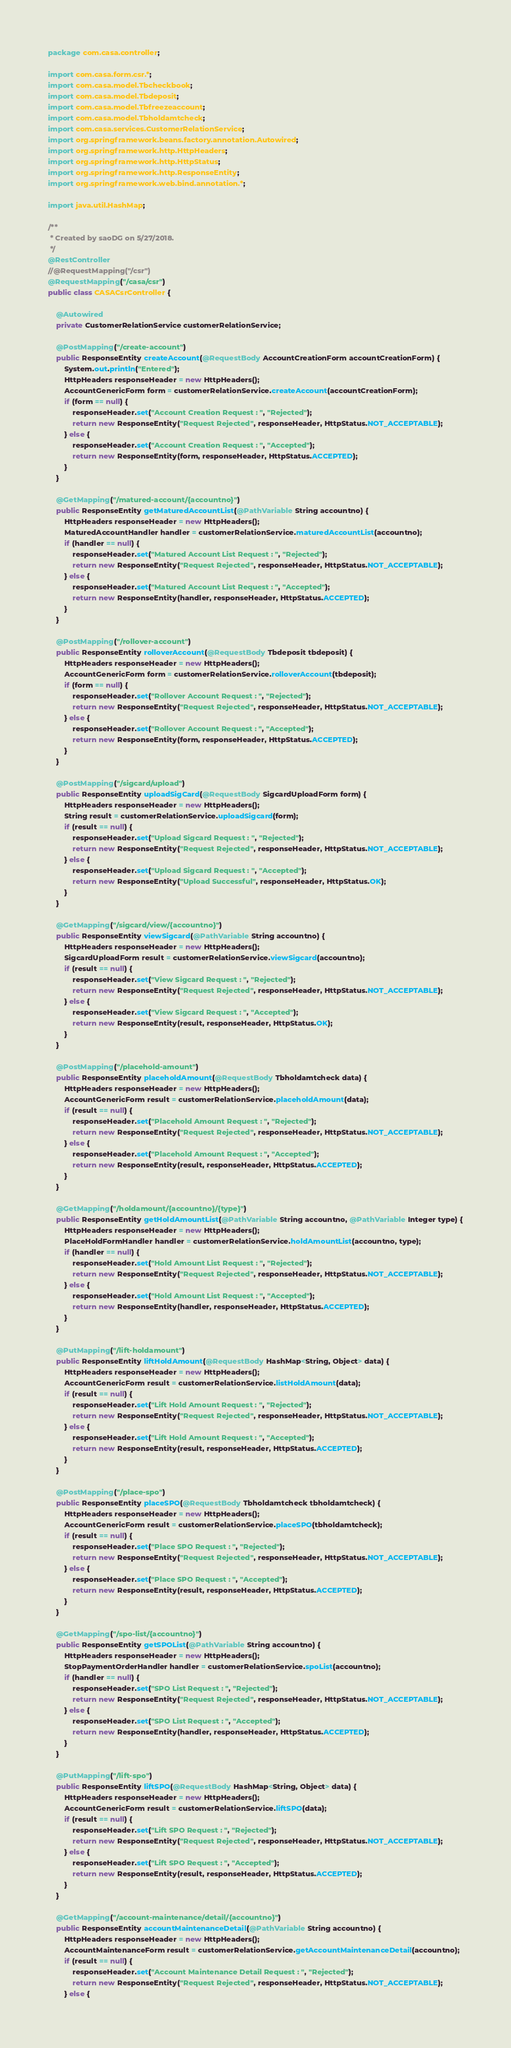Convert code to text. <code><loc_0><loc_0><loc_500><loc_500><_Java_>package com.casa.controller;

import com.casa.form.csr.*;
import com.casa.model.Tbcheckbook;
import com.casa.model.Tbdeposit;
import com.casa.model.Tbfreezeaccount;
import com.casa.model.Tbholdamtcheck;
import com.casa.services.CustomerRelationService;
import org.springframework.beans.factory.annotation.Autowired;
import org.springframework.http.HttpHeaders;
import org.springframework.http.HttpStatus;
import org.springframework.http.ResponseEntity;
import org.springframework.web.bind.annotation.*;

import java.util.HashMap;

/**
 * Created by saoDG on 5/27/2018.
 */
@RestController
//@RequestMapping("/csr")
@RequestMapping("/casa/csr")
public class CASACsrController {

    @Autowired
    private CustomerRelationService customerRelationService;

    @PostMapping("/create-account")
    public ResponseEntity createAccount(@RequestBody AccountCreationForm accountCreationForm) {
        System.out.println("Entered");
        HttpHeaders responseHeader = new HttpHeaders();
        AccountGenericForm form = customerRelationService.createAccount(accountCreationForm);
        if (form == null) {
            responseHeader.set("Account Creation Request : ", "Rejected");
            return new ResponseEntity("Request Rejected", responseHeader, HttpStatus.NOT_ACCEPTABLE);
        } else {
            responseHeader.set("Account Creation Request : ", "Accepted");
            return new ResponseEntity(form, responseHeader, HttpStatus.ACCEPTED);
        }
    }

    @GetMapping("/matured-account/{accountno}")
    public ResponseEntity getMaturedAccountList(@PathVariable String accountno) {
        HttpHeaders responseHeader = new HttpHeaders();
        MaturedAccountHandler handler = customerRelationService.maturedAccountList(accountno);
        if (handler == null) {
            responseHeader.set("Matured Account List Request : ", "Rejected");
            return new ResponseEntity("Request Rejected", responseHeader, HttpStatus.NOT_ACCEPTABLE);
        } else {
            responseHeader.set("Matured Account List Request : ", "Accepted");
            return new ResponseEntity(handler, responseHeader, HttpStatus.ACCEPTED);
        }
    }

    @PostMapping("/rollover-account")
    public ResponseEntity rolloverAccount(@RequestBody Tbdeposit tbdeposit) {
        HttpHeaders responseHeader = new HttpHeaders();
        AccountGenericForm form = customerRelationService.rolloverAccount(tbdeposit);
        if (form == null) {
            responseHeader.set("Rollover Account Request : ", "Rejected");
            return new ResponseEntity("Request Rejected", responseHeader, HttpStatus.NOT_ACCEPTABLE);
        } else {
            responseHeader.set("Rollover Account Request : ", "Accepted");
            return new ResponseEntity(form, responseHeader, HttpStatus.ACCEPTED);
        }
    }

    @PostMapping("/sigcard/upload")
    public ResponseEntity uploadSigCard(@RequestBody SigcardUploadForm form) {
        HttpHeaders responseHeader = new HttpHeaders();
        String result = customerRelationService.uploadSigcard(form);
        if (result == null) {
            responseHeader.set("Upload Sigcard Request : ", "Rejected");
            return new ResponseEntity("Request Rejected", responseHeader, HttpStatus.NOT_ACCEPTABLE);
        } else {
            responseHeader.set("Upload Sigcard Request : ", "Accepted");
            return new ResponseEntity("Upload Successful", responseHeader, HttpStatus.OK);
        }
    }

    @GetMapping("/sigcard/view/{accountno}")
    public ResponseEntity viewSigcard(@PathVariable String accountno) {
        HttpHeaders responseHeader = new HttpHeaders();
        SigcardUploadForm result = customerRelationService.viewSigcard(accountno);
        if (result == null) {
            responseHeader.set("View Sigcard Request : ", "Rejected");
            return new ResponseEntity("Request Rejected", responseHeader, HttpStatus.NOT_ACCEPTABLE);
        } else {
            responseHeader.set("View Sigcard Request : ", "Accepted");
            return new ResponseEntity(result, responseHeader, HttpStatus.OK);
        }
    }

    @PostMapping("/placehold-amount")
    public ResponseEntity placeholdAmount(@RequestBody Tbholdamtcheck data) {
        HttpHeaders responseHeader = new HttpHeaders();
        AccountGenericForm result = customerRelationService.placeholdAmount(data);
        if (result == null) {
            responseHeader.set("Placehold Amount Request : ", "Rejected");
            return new ResponseEntity("Request Rejected", responseHeader, HttpStatus.NOT_ACCEPTABLE);
        } else {
            responseHeader.set("Placehold Amount Request : ", "Accepted");
            return new ResponseEntity(result, responseHeader, HttpStatus.ACCEPTED);
        }
    }

    @GetMapping("/holdamount/{accountno}/{type}")
    public ResponseEntity getHoldAmountList(@PathVariable String accountno, @PathVariable Integer type) {
        HttpHeaders responseHeader = new HttpHeaders();
        PlaceHoldFormHandler handler = customerRelationService.holdAmountList(accountno, type);
        if (handler == null) {
            responseHeader.set("Hold Amount List Request : ", "Rejected");
            return new ResponseEntity("Request Rejected", responseHeader, HttpStatus.NOT_ACCEPTABLE);
        } else {
            responseHeader.set("Hold Amount List Request : ", "Accepted");
            return new ResponseEntity(handler, responseHeader, HttpStatus.ACCEPTED);
        }
    }

    @PutMapping("/lift-holdamount")
    public ResponseEntity liftHoldAmount(@RequestBody HashMap<String, Object> data) {
        HttpHeaders responseHeader = new HttpHeaders();
        AccountGenericForm result = customerRelationService.listHoldAmount(data);
        if (result == null) {
            responseHeader.set("Lift Hold Amount Request : ", "Rejected");
            return new ResponseEntity("Request Rejected", responseHeader, HttpStatus.NOT_ACCEPTABLE);
        } else {
            responseHeader.set("Lift Hold Amount Request : ", "Accepted");
            return new ResponseEntity(result, responseHeader, HttpStatus.ACCEPTED);
        }
    }

    @PostMapping("/place-spo")
    public ResponseEntity placeSPO(@RequestBody Tbholdamtcheck tbholdamtcheck) {
        HttpHeaders responseHeader = new HttpHeaders();
        AccountGenericForm result = customerRelationService.placeSPO(tbholdamtcheck);
        if (result == null) {
            responseHeader.set("Place SPO Request : ", "Rejected");
            return new ResponseEntity("Request Rejected", responseHeader, HttpStatus.NOT_ACCEPTABLE);
        } else {
            responseHeader.set("Place SPO Request : ", "Accepted");
            return new ResponseEntity(result, responseHeader, HttpStatus.ACCEPTED);
        }
    }

    @GetMapping("/spo-list/{accountno}")
    public ResponseEntity getSPOList(@PathVariable String accountno) {
        HttpHeaders responseHeader = new HttpHeaders();
        StopPaymentOrderHandler handler = customerRelationService.spoList(accountno);
        if (handler == null) {
            responseHeader.set("SPO List Request : ", "Rejected");
            return new ResponseEntity("Request Rejected", responseHeader, HttpStatus.NOT_ACCEPTABLE);
        } else {
            responseHeader.set("SPO List Request : ", "Accepted");
            return new ResponseEntity(handler, responseHeader, HttpStatus.ACCEPTED);
        }
    }

    @PutMapping("/lift-spo")
    public ResponseEntity liftSPO(@RequestBody HashMap<String, Object> data) {
        HttpHeaders responseHeader = new HttpHeaders();
        AccountGenericForm result = customerRelationService.liftSPO(data);
        if (result == null) {
            responseHeader.set("Lift SPO Request : ", "Rejected");
            return new ResponseEntity("Request Rejected", responseHeader, HttpStatus.NOT_ACCEPTABLE);
        } else {
            responseHeader.set("Lift SPO Request : ", "Accepted");
            return new ResponseEntity(result, responseHeader, HttpStatus.ACCEPTED);
        }
    }

    @GetMapping("/account-maintenance/detail/{accountno}")
    public ResponseEntity accountMaintenanceDetail(@PathVariable String accountno) {
        HttpHeaders responseHeader = new HttpHeaders();
        AccountMaintenanceForm result = customerRelationService.getAccountMaintenanceDetail(accountno);
        if (result == null) {
            responseHeader.set("Account Maintenance Detail Request : ", "Rejected");
            return new ResponseEntity("Request Rejected", responseHeader, HttpStatus.NOT_ACCEPTABLE);
        } else {</code> 